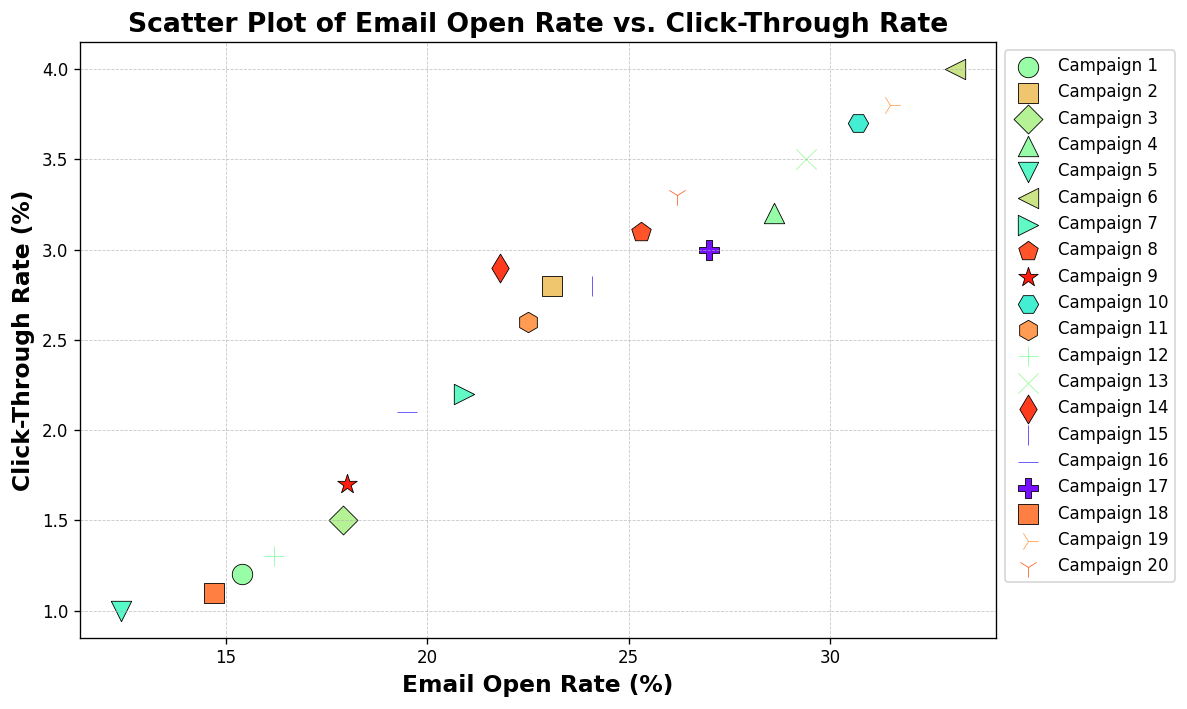what is the average email open rate of all campaigns? To calculate the average email open rate, sum up the email open rates of all 20 campaigns and then divide by 20. Sum is 15.4 + 23.1 + 17.9 + 28.6 + 12.4 + 33.1 + 20.9 + 25.3 + 18.0 + 30.7 + 22.5 + 16.2 + 29.4 + 21.8 + 24.1 + 19.5 + 27.0 + 14.7 + 31.5 + 26.2 = 458.2. Average is 458.2 / 20 = 22.91
Answer: 22.91 Which campaign has the highest click-through rate? Identify the campaign with the highest point in the vertical (click-through rate) axis. Campaign 6 has the highest click-through rate of 4.0%.
Answer: Campaign 6 Which group of campaigns has an open rate greater than 25% and their click-through rates? Locate the campaigns on the scatter plot where the email open rate is above 25%. These campaigns are 4 (28.6, 3.2), 6 (33.1, 4.0), 10 (30.7, 3.7), 13 (29.4, 3.5), 17 (27.0, 3.0), 19 (31.5, 3.8), 20 (26.2, 3.3).
Answer: Campaigns 4, 6, 10, 13, 17, 19, 20 with click-through rates of 3.2, 4.0, 3.7, 3.5, 3.0, 3.8, 3.3 What is the difference in click-through rate between the campaigns with the highest and the lowest email open rates? Identify the campaigns with the highest and lowest email open rates (6 with 33.1% and 5 with 12.4%, respectively). Their respective click-through rates are 4.0% and 1.0%. The difference is 4.0 - 1.0 = 3.0.
Answer: 3.0 Which campaign has both an email open rate greater than 25% and a click-through rate less than 3%? Find the campaign(s) where the email open rate is greater than 25% and the click-through rate is less than 3%. Campaign 17 fits this criterion with an email open rate of 27.0% and a click-through rate of 3.0%.
Answer: Campaign 17 Which campaigns fall into the top 25% for email open rate? The campaigns need to be in the top 5 ranges (as 25% of 20 is 5). The five highest email open rates are 33.1, 31.5, 30.7, 29.4, and 28.6, corresponding to campaigns 6, 19, 10, 13, and 4.
Answer: Campaigns 6, 19, 10, 13, 4 Is there a general trend or relationship visible between email open rates and click-through rates? Examine the overall direction of the points on the scatter plot. As the email open rate increases, the click-through rates also tend to increase, indicating a positive correlation.
Answer: Positive correlation 